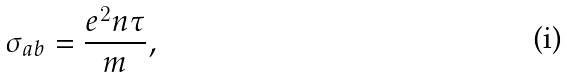<formula> <loc_0><loc_0><loc_500><loc_500>\sigma _ { a b } = \frac { e ^ { 2 } n \tau } { m } ,</formula> 